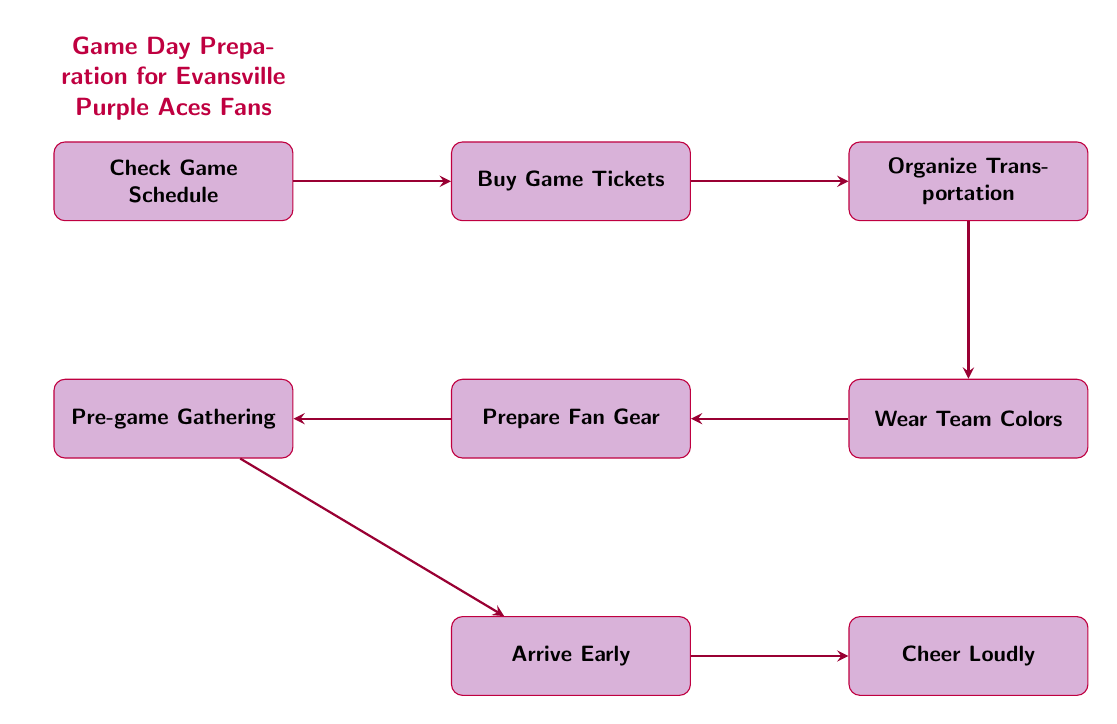What is the first step in the game day preparation? The first step indicated in the flow chart is "Check Game Schedule," which directs fans to confirm the date and time of the game.
Answer: Check Game Schedule How many nodes are present in the diagram? By counting, the diagram includes a total of eight nodes representing different steps in the game day preparation.
Answer: 8 What comes after "Buy Game Tickets"? Following "Buy Game Tickets," the next step in the flow is "Organize Transportation," which indicates that fans should plan how to get to the game.
Answer: Organize Transportation Which node suggests wearing team apparel? The node that suggests wearing team apparel is "Wear Team Colors," which encourages fans to display their support by wearing Evansville Purple Aces gear.
Answer: Wear Team Colors If a fan completes "Pre-game Gathering," what is the next action? The action that follows "Pre-game Gathering" is "Arrive Early," suggesting fans should get to the Ford Center in advance of the game.
Answer: Arrive Early What is the relationship between "Prepare Fan Gear" and "Cheer Loudly"? "Prepare Fan Gear" is a step that leads to "Pre-game Gathering," and "Cheer Loudly" is the final action in the sequence, indicating that fan preparation contributes to cheering during the game.
Answer: Sequential connection How many edges are represented in the diagram? There are seven arrows indicating the flow from one action to the next, which corresponds to the transitions or connections between the eight nodes.
Answer: 7 What type of activities can fans do at "Pre-game Gathering"? At "Pre-game Gathering," fans are encouraged to join fellow supporters for food and drinks at local spots prior to going to the game.
Answer: Food and drinks What is the overall objective of this flow chart? The overall objective of the flow chart is to outline a game day preparation schedule specifically designed for fans of the Evansville Purple Aces men's basketball team.
Answer: Game day preparation schedule 